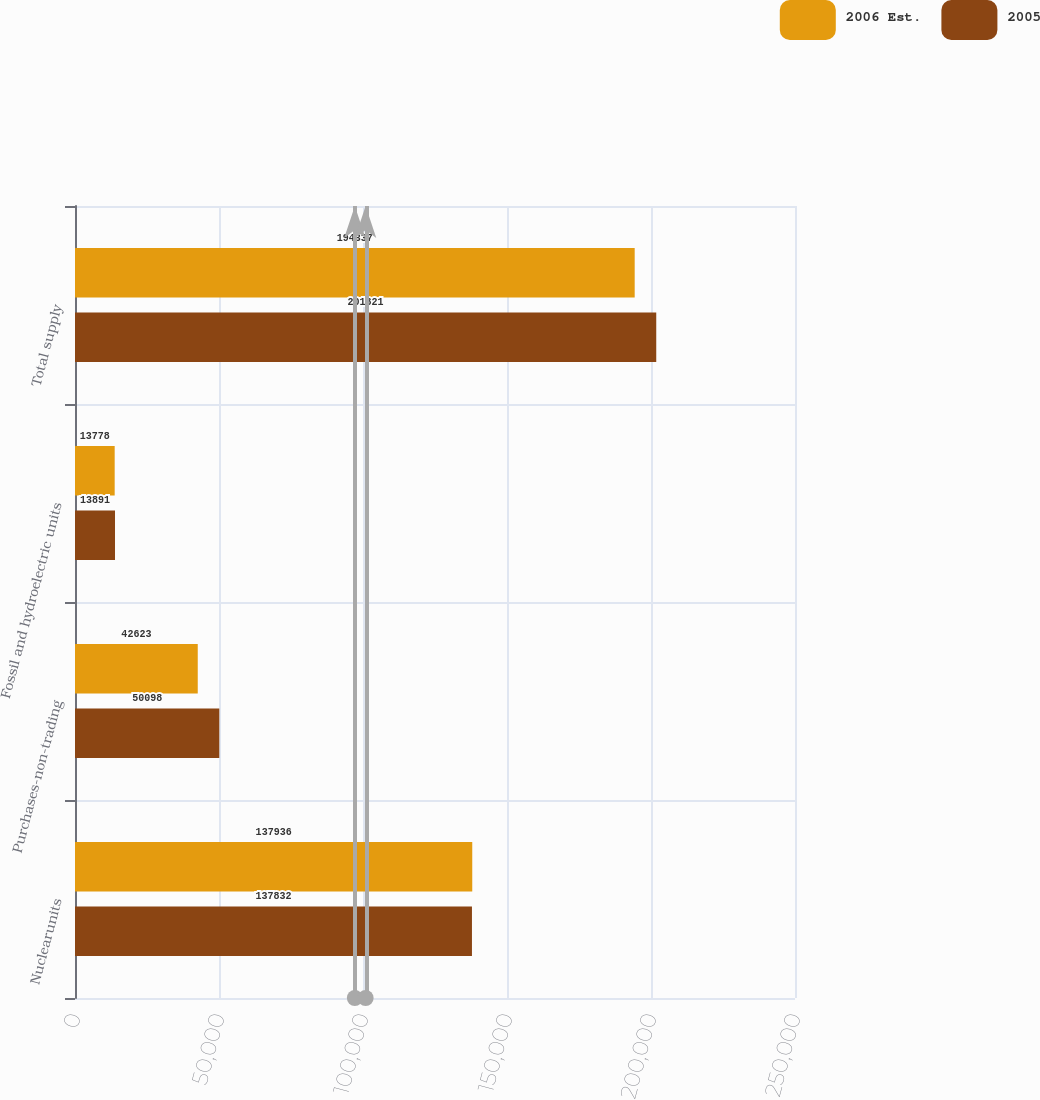Convert chart. <chart><loc_0><loc_0><loc_500><loc_500><stacked_bar_chart><ecel><fcel>Nuclearunits<fcel>Purchases-non-trading<fcel>Fossil and hydroelectric units<fcel>Total supply<nl><fcel>2006 Est.<fcel>137936<fcel>42623<fcel>13778<fcel>194337<nl><fcel>2005<fcel>137832<fcel>50098<fcel>13891<fcel>201821<nl></chart> 